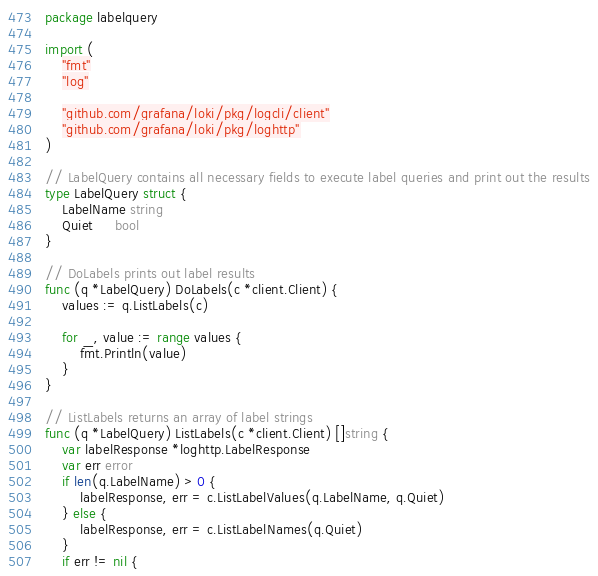<code> <loc_0><loc_0><loc_500><loc_500><_Go_>package labelquery

import (
	"fmt"
	"log"

	"github.com/grafana/loki/pkg/logcli/client"
	"github.com/grafana/loki/pkg/loghttp"
)

// LabelQuery contains all necessary fields to execute label queries and print out the results
type LabelQuery struct {
	LabelName string
	Quiet     bool
}

// DoLabels prints out label results
func (q *LabelQuery) DoLabels(c *client.Client) {
	values := q.ListLabels(c)

	for _, value := range values {
		fmt.Println(value)
	}
}

// ListLabels returns an array of label strings
func (q *LabelQuery) ListLabels(c *client.Client) []string {
	var labelResponse *loghttp.LabelResponse
	var err error
	if len(q.LabelName) > 0 {
		labelResponse, err = c.ListLabelValues(q.LabelName, q.Quiet)
	} else {
		labelResponse, err = c.ListLabelNames(q.Quiet)
	}
	if err != nil {</code> 